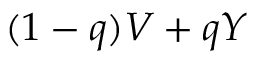<formula> <loc_0><loc_0><loc_500><loc_500>( 1 - q ) V + q Y</formula> 